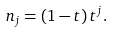<formula> <loc_0><loc_0><loc_500><loc_500>n _ { j } = ( 1 - t ) \, t ^ { j } .</formula> 